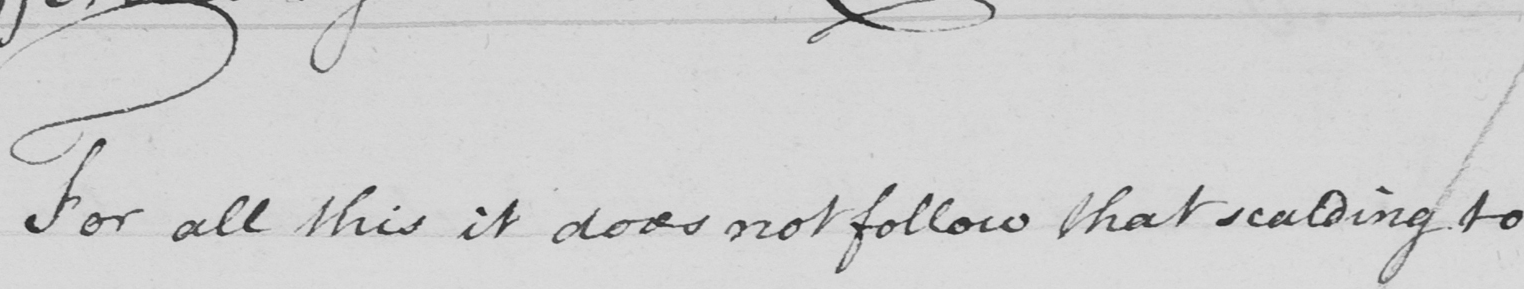Transcribe the text shown in this historical manuscript line. For all this is does not follow that scalding to 